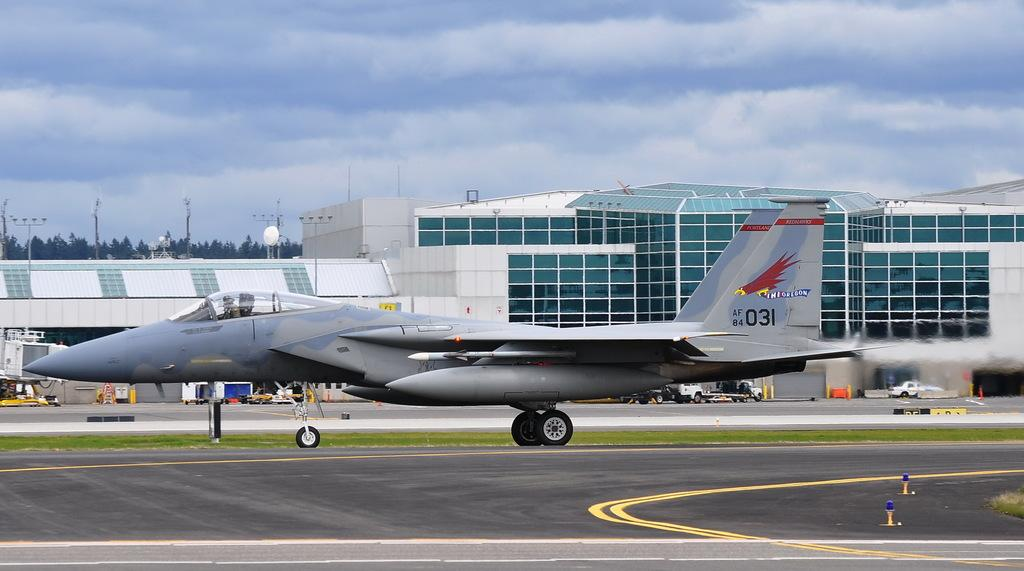<image>
Render a clear and concise summary of the photo. A jet is on a runway with the number 031 and a red hawk on its tail wing. 